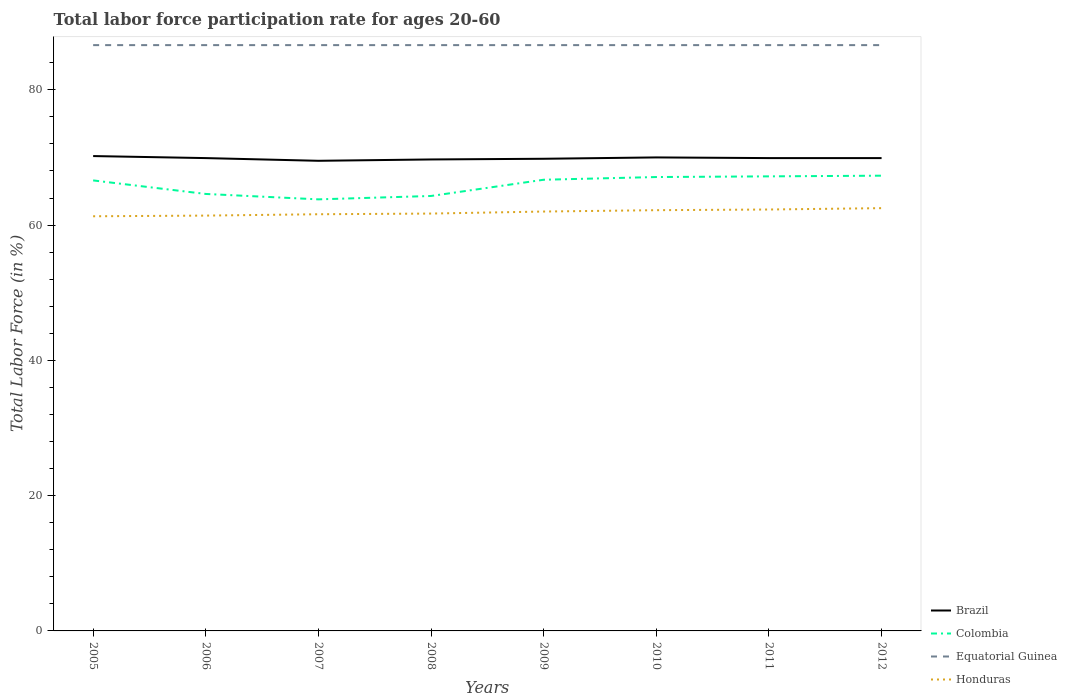Across all years, what is the maximum labor force participation rate in Brazil?
Offer a terse response. 69.5. In which year was the labor force participation rate in Honduras maximum?
Give a very brief answer. 2005. What is the total labor force participation rate in Brazil in the graph?
Provide a short and direct response. -0.4. What is the difference between the highest and the second highest labor force participation rate in Honduras?
Your answer should be compact. 1.2. Is the labor force participation rate in Brazil strictly greater than the labor force participation rate in Equatorial Guinea over the years?
Your response must be concise. Yes. How many years are there in the graph?
Make the answer very short. 8. What is the difference between two consecutive major ticks on the Y-axis?
Offer a very short reply. 20. Are the values on the major ticks of Y-axis written in scientific E-notation?
Your answer should be very brief. No. Does the graph contain any zero values?
Provide a short and direct response. No. Does the graph contain grids?
Offer a terse response. No. Where does the legend appear in the graph?
Offer a very short reply. Bottom right. What is the title of the graph?
Give a very brief answer. Total labor force participation rate for ages 20-60. Does "Palau" appear as one of the legend labels in the graph?
Keep it short and to the point. No. What is the Total Labor Force (in %) in Brazil in 2005?
Offer a terse response. 70.2. What is the Total Labor Force (in %) of Colombia in 2005?
Give a very brief answer. 66.6. What is the Total Labor Force (in %) in Equatorial Guinea in 2005?
Your answer should be very brief. 86.6. What is the Total Labor Force (in %) in Honduras in 2005?
Give a very brief answer. 61.3. What is the Total Labor Force (in %) of Brazil in 2006?
Make the answer very short. 69.9. What is the Total Labor Force (in %) of Colombia in 2006?
Offer a very short reply. 64.6. What is the Total Labor Force (in %) in Equatorial Guinea in 2006?
Your answer should be very brief. 86.6. What is the Total Labor Force (in %) of Honduras in 2006?
Your answer should be compact. 61.4. What is the Total Labor Force (in %) in Brazil in 2007?
Provide a short and direct response. 69.5. What is the Total Labor Force (in %) of Colombia in 2007?
Offer a terse response. 63.8. What is the Total Labor Force (in %) in Equatorial Guinea in 2007?
Provide a short and direct response. 86.6. What is the Total Labor Force (in %) in Honduras in 2007?
Your answer should be compact. 61.6. What is the Total Labor Force (in %) in Brazil in 2008?
Your answer should be compact. 69.7. What is the Total Labor Force (in %) of Colombia in 2008?
Your answer should be compact. 64.3. What is the Total Labor Force (in %) of Equatorial Guinea in 2008?
Your answer should be compact. 86.6. What is the Total Labor Force (in %) in Honduras in 2008?
Keep it short and to the point. 61.7. What is the Total Labor Force (in %) in Brazil in 2009?
Keep it short and to the point. 69.8. What is the Total Labor Force (in %) in Colombia in 2009?
Provide a succinct answer. 66.7. What is the Total Labor Force (in %) in Equatorial Guinea in 2009?
Provide a short and direct response. 86.6. What is the Total Labor Force (in %) of Colombia in 2010?
Offer a terse response. 67.1. What is the Total Labor Force (in %) of Equatorial Guinea in 2010?
Make the answer very short. 86.6. What is the Total Labor Force (in %) in Honduras in 2010?
Provide a succinct answer. 62.2. What is the Total Labor Force (in %) of Brazil in 2011?
Provide a succinct answer. 69.9. What is the Total Labor Force (in %) in Colombia in 2011?
Make the answer very short. 67.2. What is the Total Labor Force (in %) in Equatorial Guinea in 2011?
Your answer should be very brief. 86.6. What is the Total Labor Force (in %) of Honduras in 2011?
Keep it short and to the point. 62.3. What is the Total Labor Force (in %) in Brazil in 2012?
Your response must be concise. 69.9. What is the Total Labor Force (in %) of Colombia in 2012?
Ensure brevity in your answer.  67.3. What is the Total Labor Force (in %) in Equatorial Guinea in 2012?
Your answer should be compact. 86.6. What is the Total Labor Force (in %) of Honduras in 2012?
Keep it short and to the point. 62.5. Across all years, what is the maximum Total Labor Force (in %) in Brazil?
Your answer should be compact. 70.2. Across all years, what is the maximum Total Labor Force (in %) in Colombia?
Offer a very short reply. 67.3. Across all years, what is the maximum Total Labor Force (in %) of Equatorial Guinea?
Keep it short and to the point. 86.6. Across all years, what is the maximum Total Labor Force (in %) of Honduras?
Your response must be concise. 62.5. Across all years, what is the minimum Total Labor Force (in %) in Brazil?
Make the answer very short. 69.5. Across all years, what is the minimum Total Labor Force (in %) of Colombia?
Keep it short and to the point. 63.8. Across all years, what is the minimum Total Labor Force (in %) of Equatorial Guinea?
Your answer should be very brief. 86.6. Across all years, what is the minimum Total Labor Force (in %) of Honduras?
Ensure brevity in your answer.  61.3. What is the total Total Labor Force (in %) of Brazil in the graph?
Give a very brief answer. 558.9. What is the total Total Labor Force (in %) in Colombia in the graph?
Provide a short and direct response. 527.6. What is the total Total Labor Force (in %) of Equatorial Guinea in the graph?
Keep it short and to the point. 692.8. What is the total Total Labor Force (in %) in Honduras in the graph?
Your answer should be compact. 495. What is the difference between the Total Labor Force (in %) of Brazil in 2005 and that in 2006?
Make the answer very short. 0.3. What is the difference between the Total Labor Force (in %) in Colombia in 2005 and that in 2006?
Your response must be concise. 2. What is the difference between the Total Labor Force (in %) of Equatorial Guinea in 2005 and that in 2006?
Your answer should be compact. 0. What is the difference between the Total Labor Force (in %) of Honduras in 2005 and that in 2006?
Give a very brief answer. -0.1. What is the difference between the Total Labor Force (in %) of Colombia in 2005 and that in 2007?
Offer a very short reply. 2.8. What is the difference between the Total Labor Force (in %) in Equatorial Guinea in 2005 and that in 2007?
Make the answer very short. 0. What is the difference between the Total Labor Force (in %) in Brazil in 2005 and that in 2008?
Offer a terse response. 0.5. What is the difference between the Total Labor Force (in %) in Equatorial Guinea in 2005 and that in 2009?
Offer a very short reply. 0. What is the difference between the Total Labor Force (in %) in Brazil in 2005 and that in 2010?
Make the answer very short. 0.2. What is the difference between the Total Labor Force (in %) in Colombia in 2005 and that in 2010?
Give a very brief answer. -0.5. What is the difference between the Total Labor Force (in %) in Equatorial Guinea in 2005 and that in 2010?
Make the answer very short. 0. What is the difference between the Total Labor Force (in %) in Equatorial Guinea in 2005 and that in 2011?
Keep it short and to the point. 0. What is the difference between the Total Labor Force (in %) in Honduras in 2005 and that in 2011?
Offer a terse response. -1. What is the difference between the Total Labor Force (in %) of Colombia in 2005 and that in 2012?
Provide a short and direct response. -0.7. What is the difference between the Total Labor Force (in %) of Honduras in 2005 and that in 2012?
Keep it short and to the point. -1.2. What is the difference between the Total Labor Force (in %) of Brazil in 2006 and that in 2007?
Offer a terse response. 0.4. What is the difference between the Total Labor Force (in %) in Brazil in 2006 and that in 2008?
Your answer should be very brief. 0.2. What is the difference between the Total Labor Force (in %) of Colombia in 2006 and that in 2008?
Provide a succinct answer. 0.3. What is the difference between the Total Labor Force (in %) of Equatorial Guinea in 2006 and that in 2008?
Make the answer very short. 0. What is the difference between the Total Labor Force (in %) in Brazil in 2006 and that in 2009?
Offer a terse response. 0.1. What is the difference between the Total Labor Force (in %) in Equatorial Guinea in 2006 and that in 2009?
Provide a succinct answer. 0. What is the difference between the Total Labor Force (in %) in Brazil in 2006 and that in 2010?
Provide a succinct answer. -0.1. What is the difference between the Total Labor Force (in %) in Colombia in 2006 and that in 2010?
Offer a terse response. -2.5. What is the difference between the Total Labor Force (in %) of Honduras in 2006 and that in 2010?
Offer a very short reply. -0.8. What is the difference between the Total Labor Force (in %) in Brazil in 2006 and that in 2011?
Offer a very short reply. 0. What is the difference between the Total Labor Force (in %) of Colombia in 2006 and that in 2011?
Ensure brevity in your answer.  -2.6. What is the difference between the Total Labor Force (in %) of Honduras in 2006 and that in 2011?
Make the answer very short. -0.9. What is the difference between the Total Labor Force (in %) of Brazil in 2006 and that in 2012?
Provide a succinct answer. 0. What is the difference between the Total Labor Force (in %) of Colombia in 2006 and that in 2012?
Your answer should be very brief. -2.7. What is the difference between the Total Labor Force (in %) of Equatorial Guinea in 2007 and that in 2008?
Your response must be concise. 0. What is the difference between the Total Labor Force (in %) in Honduras in 2007 and that in 2008?
Give a very brief answer. -0.1. What is the difference between the Total Labor Force (in %) of Equatorial Guinea in 2007 and that in 2009?
Provide a succinct answer. 0. What is the difference between the Total Labor Force (in %) of Honduras in 2007 and that in 2009?
Provide a short and direct response. -0.4. What is the difference between the Total Labor Force (in %) of Colombia in 2007 and that in 2010?
Provide a short and direct response. -3.3. What is the difference between the Total Labor Force (in %) in Equatorial Guinea in 2007 and that in 2010?
Ensure brevity in your answer.  0. What is the difference between the Total Labor Force (in %) in Honduras in 2007 and that in 2010?
Ensure brevity in your answer.  -0.6. What is the difference between the Total Labor Force (in %) in Brazil in 2007 and that in 2011?
Provide a short and direct response. -0.4. What is the difference between the Total Labor Force (in %) of Equatorial Guinea in 2007 and that in 2011?
Give a very brief answer. 0. What is the difference between the Total Labor Force (in %) in Brazil in 2007 and that in 2012?
Offer a terse response. -0.4. What is the difference between the Total Labor Force (in %) in Colombia in 2007 and that in 2012?
Keep it short and to the point. -3.5. What is the difference between the Total Labor Force (in %) in Equatorial Guinea in 2007 and that in 2012?
Make the answer very short. 0. What is the difference between the Total Labor Force (in %) in Honduras in 2007 and that in 2012?
Your response must be concise. -0.9. What is the difference between the Total Labor Force (in %) in Brazil in 2008 and that in 2009?
Offer a terse response. -0.1. What is the difference between the Total Labor Force (in %) in Honduras in 2008 and that in 2009?
Keep it short and to the point. -0.3. What is the difference between the Total Labor Force (in %) in Brazil in 2008 and that in 2010?
Provide a short and direct response. -0.3. What is the difference between the Total Labor Force (in %) in Colombia in 2008 and that in 2010?
Your response must be concise. -2.8. What is the difference between the Total Labor Force (in %) in Honduras in 2008 and that in 2010?
Keep it short and to the point. -0.5. What is the difference between the Total Labor Force (in %) of Equatorial Guinea in 2008 and that in 2011?
Offer a very short reply. 0. What is the difference between the Total Labor Force (in %) in Colombia in 2008 and that in 2012?
Your answer should be very brief. -3. What is the difference between the Total Labor Force (in %) of Equatorial Guinea in 2008 and that in 2012?
Your response must be concise. 0. What is the difference between the Total Labor Force (in %) in Honduras in 2008 and that in 2012?
Your response must be concise. -0.8. What is the difference between the Total Labor Force (in %) of Equatorial Guinea in 2009 and that in 2010?
Ensure brevity in your answer.  0. What is the difference between the Total Labor Force (in %) in Honduras in 2009 and that in 2010?
Offer a very short reply. -0.2. What is the difference between the Total Labor Force (in %) in Brazil in 2009 and that in 2012?
Your answer should be very brief. -0.1. What is the difference between the Total Labor Force (in %) of Equatorial Guinea in 2009 and that in 2012?
Give a very brief answer. 0. What is the difference between the Total Labor Force (in %) of Honduras in 2009 and that in 2012?
Your response must be concise. -0.5. What is the difference between the Total Labor Force (in %) in Brazil in 2010 and that in 2011?
Give a very brief answer. 0.1. What is the difference between the Total Labor Force (in %) in Honduras in 2010 and that in 2011?
Give a very brief answer. -0.1. What is the difference between the Total Labor Force (in %) of Brazil in 2010 and that in 2012?
Your answer should be very brief. 0.1. What is the difference between the Total Labor Force (in %) in Colombia in 2010 and that in 2012?
Give a very brief answer. -0.2. What is the difference between the Total Labor Force (in %) in Brazil in 2005 and the Total Labor Force (in %) in Colombia in 2006?
Give a very brief answer. 5.6. What is the difference between the Total Labor Force (in %) of Brazil in 2005 and the Total Labor Force (in %) of Equatorial Guinea in 2006?
Provide a succinct answer. -16.4. What is the difference between the Total Labor Force (in %) in Colombia in 2005 and the Total Labor Force (in %) in Equatorial Guinea in 2006?
Make the answer very short. -20. What is the difference between the Total Labor Force (in %) of Equatorial Guinea in 2005 and the Total Labor Force (in %) of Honduras in 2006?
Ensure brevity in your answer.  25.2. What is the difference between the Total Labor Force (in %) in Brazil in 2005 and the Total Labor Force (in %) in Colombia in 2007?
Your answer should be compact. 6.4. What is the difference between the Total Labor Force (in %) in Brazil in 2005 and the Total Labor Force (in %) in Equatorial Guinea in 2007?
Offer a terse response. -16.4. What is the difference between the Total Labor Force (in %) of Brazil in 2005 and the Total Labor Force (in %) of Honduras in 2007?
Offer a terse response. 8.6. What is the difference between the Total Labor Force (in %) in Colombia in 2005 and the Total Labor Force (in %) in Equatorial Guinea in 2007?
Make the answer very short. -20. What is the difference between the Total Labor Force (in %) of Colombia in 2005 and the Total Labor Force (in %) of Honduras in 2007?
Keep it short and to the point. 5. What is the difference between the Total Labor Force (in %) of Equatorial Guinea in 2005 and the Total Labor Force (in %) of Honduras in 2007?
Your response must be concise. 25. What is the difference between the Total Labor Force (in %) in Brazil in 2005 and the Total Labor Force (in %) in Equatorial Guinea in 2008?
Make the answer very short. -16.4. What is the difference between the Total Labor Force (in %) of Equatorial Guinea in 2005 and the Total Labor Force (in %) of Honduras in 2008?
Make the answer very short. 24.9. What is the difference between the Total Labor Force (in %) of Brazil in 2005 and the Total Labor Force (in %) of Equatorial Guinea in 2009?
Your answer should be very brief. -16.4. What is the difference between the Total Labor Force (in %) in Brazil in 2005 and the Total Labor Force (in %) in Honduras in 2009?
Provide a succinct answer. 8.2. What is the difference between the Total Labor Force (in %) in Colombia in 2005 and the Total Labor Force (in %) in Honduras in 2009?
Provide a short and direct response. 4.6. What is the difference between the Total Labor Force (in %) of Equatorial Guinea in 2005 and the Total Labor Force (in %) of Honduras in 2009?
Keep it short and to the point. 24.6. What is the difference between the Total Labor Force (in %) of Brazil in 2005 and the Total Labor Force (in %) of Colombia in 2010?
Keep it short and to the point. 3.1. What is the difference between the Total Labor Force (in %) of Brazil in 2005 and the Total Labor Force (in %) of Equatorial Guinea in 2010?
Your answer should be very brief. -16.4. What is the difference between the Total Labor Force (in %) in Brazil in 2005 and the Total Labor Force (in %) in Honduras in 2010?
Provide a short and direct response. 8. What is the difference between the Total Labor Force (in %) of Colombia in 2005 and the Total Labor Force (in %) of Equatorial Guinea in 2010?
Provide a short and direct response. -20. What is the difference between the Total Labor Force (in %) of Equatorial Guinea in 2005 and the Total Labor Force (in %) of Honduras in 2010?
Provide a succinct answer. 24.4. What is the difference between the Total Labor Force (in %) in Brazil in 2005 and the Total Labor Force (in %) in Equatorial Guinea in 2011?
Provide a succinct answer. -16.4. What is the difference between the Total Labor Force (in %) in Brazil in 2005 and the Total Labor Force (in %) in Honduras in 2011?
Offer a terse response. 7.9. What is the difference between the Total Labor Force (in %) in Equatorial Guinea in 2005 and the Total Labor Force (in %) in Honduras in 2011?
Provide a short and direct response. 24.3. What is the difference between the Total Labor Force (in %) of Brazil in 2005 and the Total Labor Force (in %) of Colombia in 2012?
Offer a very short reply. 2.9. What is the difference between the Total Labor Force (in %) of Brazil in 2005 and the Total Labor Force (in %) of Equatorial Guinea in 2012?
Give a very brief answer. -16.4. What is the difference between the Total Labor Force (in %) in Colombia in 2005 and the Total Labor Force (in %) in Honduras in 2012?
Offer a terse response. 4.1. What is the difference between the Total Labor Force (in %) of Equatorial Guinea in 2005 and the Total Labor Force (in %) of Honduras in 2012?
Keep it short and to the point. 24.1. What is the difference between the Total Labor Force (in %) in Brazil in 2006 and the Total Labor Force (in %) in Colombia in 2007?
Offer a terse response. 6.1. What is the difference between the Total Labor Force (in %) in Brazil in 2006 and the Total Labor Force (in %) in Equatorial Guinea in 2007?
Ensure brevity in your answer.  -16.7. What is the difference between the Total Labor Force (in %) in Colombia in 2006 and the Total Labor Force (in %) in Equatorial Guinea in 2007?
Make the answer very short. -22. What is the difference between the Total Labor Force (in %) of Equatorial Guinea in 2006 and the Total Labor Force (in %) of Honduras in 2007?
Keep it short and to the point. 25. What is the difference between the Total Labor Force (in %) of Brazil in 2006 and the Total Labor Force (in %) of Colombia in 2008?
Offer a terse response. 5.6. What is the difference between the Total Labor Force (in %) in Brazil in 2006 and the Total Labor Force (in %) in Equatorial Guinea in 2008?
Offer a very short reply. -16.7. What is the difference between the Total Labor Force (in %) of Brazil in 2006 and the Total Labor Force (in %) of Honduras in 2008?
Keep it short and to the point. 8.2. What is the difference between the Total Labor Force (in %) of Colombia in 2006 and the Total Labor Force (in %) of Honduras in 2008?
Make the answer very short. 2.9. What is the difference between the Total Labor Force (in %) of Equatorial Guinea in 2006 and the Total Labor Force (in %) of Honduras in 2008?
Ensure brevity in your answer.  24.9. What is the difference between the Total Labor Force (in %) of Brazil in 2006 and the Total Labor Force (in %) of Equatorial Guinea in 2009?
Your answer should be compact. -16.7. What is the difference between the Total Labor Force (in %) in Brazil in 2006 and the Total Labor Force (in %) in Honduras in 2009?
Give a very brief answer. 7.9. What is the difference between the Total Labor Force (in %) in Colombia in 2006 and the Total Labor Force (in %) in Equatorial Guinea in 2009?
Offer a terse response. -22. What is the difference between the Total Labor Force (in %) of Colombia in 2006 and the Total Labor Force (in %) of Honduras in 2009?
Make the answer very short. 2.6. What is the difference between the Total Labor Force (in %) in Equatorial Guinea in 2006 and the Total Labor Force (in %) in Honduras in 2009?
Your response must be concise. 24.6. What is the difference between the Total Labor Force (in %) of Brazil in 2006 and the Total Labor Force (in %) of Equatorial Guinea in 2010?
Give a very brief answer. -16.7. What is the difference between the Total Labor Force (in %) in Brazil in 2006 and the Total Labor Force (in %) in Honduras in 2010?
Give a very brief answer. 7.7. What is the difference between the Total Labor Force (in %) in Colombia in 2006 and the Total Labor Force (in %) in Equatorial Guinea in 2010?
Offer a terse response. -22. What is the difference between the Total Labor Force (in %) of Equatorial Guinea in 2006 and the Total Labor Force (in %) of Honduras in 2010?
Keep it short and to the point. 24.4. What is the difference between the Total Labor Force (in %) in Brazil in 2006 and the Total Labor Force (in %) in Equatorial Guinea in 2011?
Your response must be concise. -16.7. What is the difference between the Total Labor Force (in %) of Colombia in 2006 and the Total Labor Force (in %) of Equatorial Guinea in 2011?
Offer a terse response. -22. What is the difference between the Total Labor Force (in %) of Equatorial Guinea in 2006 and the Total Labor Force (in %) of Honduras in 2011?
Make the answer very short. 24.3. What is the difference between the Total Labor Force (in %) in Brazil in 2006 and the Total Labor Force (in %) in Equatorial Guinea in 2012?
Give a very brief answer. -16.7. What is the difference between the Total Labor Force (in %) of Brazil in 2006 and the Total Labor Force (in %) of Honduras in 2012?
Your response must be concise. 7.4. What is the difference between the Total Labor Force (in %) of Equatorial Guinea in 2006 and the Total Labor Force (in %) of Honduras in 2012?
Your answer should be compact. 24.1. What is the difference between the Total Labor Force (in %) of Brazil in 2007 and the Total Labor Force (in %) of Equatorial Guinea in 2008?
Your answer should be compact. -17.1. What is the difference between the Total Labor Force (in %) of Brazil in 2007 and the Total Labor Force (in %) of Honduras in 2008?
Your answer should be compact. 7.8. What is the difference between the Total Labor Force (in %) in Colombia in 2007 and the Total Labor Force (in %) in Equatorial Guinea in 2008?
Provide a succinct answer. -22.8. What is the difference between the Total Labor Force (in %) in Equatorial Guinea in 2007 and the Total Labor Force (in %) in Honduras in 2008?
Your answer should be very brief. 24.9. What is the difference between the Total Labor Force (in %) in Brazil in 2007 and the Total Labor Force (in %) in Colombia in 2009?
Offer a very short reply. 2.8. What is the difference between the Total Labor Force (in %) of Brazil in 2007 and the Total Labor Force (in %) of Equatorial Guinea in 2009?
Make the answer very short. -17.1. What is the difference between the Total Labor Force (in %) in Brazil in 2007 and the Total Labor Force (in %) in Honduras in 2009?
Offer a very short reply. 7.5. What is the difference between the Total Labor Force (in %) of Colombia in 2007 and the Total Labor Force (in %) of Equatorial Guinea in 2009?
Keep it short and to the point. -22.8. What is the difference between the Total Labor Force (in %) of Colombia in 2007 and the Total Labor Force (in %) of Honduras in 2009?
Ensure brevity in your answer.  1.8. What is the difference between the Total Labor Force (in %) in Equatorial Guinea in 2007 and the Total Labor Force (in %) in Honduras in 2009?
Give a very brief answer. 24.6. What is the difference between the Total Labor Force (in %) in Brazil in 2007 and the Total Labor Force (in %) in Equatorial Guinea in 2010?
Make the answer very short. -17.1. What is the difference between the Total Labor Force (in %) in Colombia in 2007 and the Total Labor Force (in %) in Equatorial Guinea in 2010?
Give a very brief answer. -22.8. What is the difference between the Total Labor Force (in %) of Equatorial Guinea in 2007 and the Total Labor Force (in %) of Honduras in 2010?
Your answer should be very brief. 24.4. What is the difference between the Total Labor Force (in %) of Brazil in 2007 and the Total Labor Force (in %) of Colombia in 2011?
Your answer should be very brief. 2.3. What is the difference between the Total Labor Force (in %) in Brazil in 2007 and the Total Labor Force (in %) in Equatorial Guinea in 2011?
Keep it short and to the point. -17.1. What is the difference between the Total Labor Force (in %) in Brazil in 2007 and the Total Labor Force (in %) in Honduras in 2011?
Give a very brief answer. 7.2. What is the difference between the Total Labor Force (in %) of Colombia in 2007 and the Total Labor Force (in %) of Equatorial Guinea in 2011?
Provide a short and direct response. -22.8. What is the difference between the Total Labor Force (in %) in Colombia in 2007 and the Total Labor Force (in %) in Honduras in 2011?
Provide a short and direct response. 1.5. What is the difference between the Total Labor Force (in %) in Equatorial Guinea in 2007 and the Total Labor Force (in %) in Honduras in 2011?
Provide a succinct answer. 24.3. What is the difference between the Total Labor Force (in %) of Brazil in 2007 and the Total Labor Force (in %) of Equatorial Guinea in 2012?
Offer a very short reply. -17.1. What is the difference between the Total Labor Force (in %) of Colombia in 2007 and the Total Labor Force (in %) of Equatorial Guinea in 2012?
Provide a succinct answer. -22.8. What is the difference between the Total Labor Force (in %) of Equatorial Guinea in 2007 and the Total Labor Force (in %) of Honduras in 2012?
Offer a very short reply. 24.1. What is the difference between the Total Labor Force (in %) in Brazil in 2008 and the Total Labor Force (in %) in Equatorial Guinea in 2009?
Keep it short and to the point. -16.9. What is the difference between the Total Labor Force (in %) of Colombia in 2008 and the Total Labor Force (in %) of Equatorial Guinea in 2009?
Your answer should be very brief. -22.3. What is the difference between the Total Labor Force (in %) in Colombia in 2008 and the Total Labor Force (in %) in Honduras in 2009?
Keep it short and to the point. 2.3. What is the difference between the Total Labor Force (in %) of Equatorial Guinea in 2008 and the Total Labor Force (in %) of Honduras in 2009?
Ensure brevity in your answer.  24.6. What is the difference between the Total Labor Force (in %) of Brazil in 2008 and the Total Labor Force (in %) of Colombia in 2010?
Give a very brief answer. 2.6. What is the difference between the Total Labor Force (in %) in Brazil in 2008 and the Total Labor Force (in %) in Equatorial Guinea in 2010?
Provide a short and direct response. -16.9. What is the difference between the Total Labor Force (in %) of Brazil in 2008 and the Total Labor Force (in %) of Honduras in 2010?
Provide a short and direct response. 7.5. What is the difference between the Total Labor Force (in %) of Colombia in 2008 and the Total Labor Force (in %) of Equatorial Guinea in 2010?
Give a very brief answer. -22.3. What is the difference between the Total Labor Force (in %) in Equatorial Guinea in 2008 and the Total Labor Force (in %) in Honduras in 2010?
Ensure brevity in your answer.  24.4. What is the difference between the Total Labor Force (in %) of Brazil in 2008 and the Total Labor Force (in %) of Equatorial Guinea in 2011?
Your answer should be very brief. -16.9. What is the difference between the Total Labor Force (in %) in Colombia in 2008 and the Total Labor Force (in %) in Equatorial Guinea in 2011?
Give a very brief answer. -22.3. What is the difference between the Total Labor Force (in %) of Colombia in 2008 and the Total Labor Force (in %) of Honduras in 2011?
Offer a very short reply. 2. What is the difference between the Total Labor Force (in %) in Equatorial Guinea in 2008 and the Total Labor Force (in %) in Honduras in 2011?
Provide a short and direct response. 24.3. What is the difference between the Total Labor Force (in %) of Brazil in 2008 and the Total Labor Force (in %) of Colombia in 2012?
Provide a short and direct response. 2.4. What is the difference between the Total Labor Force (in %) in Brazil in 2008 and the Total Labor Force (in %) in Equatorial Guinea in 2012?
Keep it short and to the point. -16.9. What is the difference between the Total Labor Force (in %) of Brazil in 2008 and the Total Labor Force (in %) of Honduras in 2012?
Provide a short and direct response. 7.2. What is the difference between the Total Labor Force (in %) in Colombia in 2008 and the Total Labor Force (in %) in Equatorial Guinea in 2012?
Your response must be concise. -22.3. What is the difference between the Total Labor Force (in %) of Colombia in 2008 and the Total Labor Force (in %) of Honduras in 2012?
Offer a terse response. 1.8. What is the difference between the Total Labor Force (in %) in Equatorial Guinea in 2008 and the Total Labor Force (in %) in Honduras in 2012?
Your answer should be very brief. 24.1. What is the difference between the Total Labor Force (in %) in Brazil in 2009 and the Total Labor Force (in %) in Equatorial Guinea in 2010?
Offer a terse response. -16.8. What is the difference between the Total Labor Force (in %) in Brazil in 2009 and the Total Labor Force (in %) in Honduras in 2010?
Offer a very short reply. 7.6. What is the difference between the Total Labor Force (in %) in Colombia in 2009 and the Total Labor Force (in %) in Equatorial Guinea in 2010?
Make the answer very short. -19.9. What is the difference between the Total Labor Force (in %) in Colombia in 2009 and the Total Labor Force (in %) in Honduras in 2010?
Make the answer very short. 4.5. What is the difference between the Total Labor Force (in %) of Equatorial Guinea in 2009 and the Total Labor Force (in %) of Honduras in 2010?
Your answer should be very brief. 24.4. What is the difference between the Total Labor Force (in %) in Brazil in 2009 and the Total Labor Force (in %) in Colombia in 2011?
Offer a terse response. 2.6. What is the difference between the Total Labor Force (in %) of Brazil in 2009 and the Total Labor Force (in %) of Equatorial Guinea in 2011?
Provide a succinct answer. -16.8. What is the difference between the Total Labor Force (in %) of Colombia in 2009 and the Total Labor Force (in %) of Equatorial Guinea in 2011?
Ensure brevity in your answer.  -19.9. What is the difference between the Total Labor Force (in %) of Colombia in 2009 and the Total Labor Force (in %) of Honduras in 2011?
Ensure brevity in your answer.  4.4. What is the difference between the Total Labor Force (in %) in Equatorial Guinea in 2009 and the Total Labor Force (in %) in Honduras in 2011?
Your answer should be compact. 24.3. What is the difference between the Total Labor Force (in %) in Brazil in 2009 and the Total Labor Force (in %) in Colombia in 2012?
Provide a succinct answer. 2.5. What is the difference between the Total Labor Force (in %) in Brazil in 2009 and the Total Labor Force (in %) in Equatorial Guinea in 2012?
Your answer should be compact. -16.8. What is the difference between the Total Labor Force (in %) of Brazil in 2009 and the Total Labor Force (in %) of Honduras in 2012?
Keep it short and to the point. 7.3. What is the difference between the Total Labor Force (in %) of Colombia in 2009 and the Total Labor Force (in %) of Equatorial Guinea in 2012?
Provide a short and direct response. -19.9. What is the difference between the Total Labor Force (in %) of Equatorial Guinea in 2009 and the Total Labor Force (in %) of Honduras in 2012?
Keep it short and to the point. 24.1. What is the difference between the Total Labor Force (in %) in Brazil in 2010 and the Total Labor Force (in %) in Colombia in 2011?
Make the answer very short. 2.8. What is the difference between the Total Labor Force (in %) in Brazil in 2010 and the Total Labor Force (in %) in Equatorial Guinea in 2011?
Provide a short and direct response. -16.6. What is the difference between the Total Labor Force (in %) of Colombia in 2010 and the Total Labor Force (in %) of Equatorial Guinea in 2011?
Ensure brevity in your answer.  -19.5. What is the difference between the Total Labor Force (in %) in Equatorial Guinea in 2010 and the Total Labor Force (in %) in Honduras in 2011?
Make the answer very short. 24.3. What is the difference between the Total Labor Force (in %) in Brazil in 2010 and the Total Labor Force (in %) in Equatorial Guinea in 2012?
Provide a succinct answer. -16.6. What is the difference between the Total Labor Force (in %) of Colombia in 2010 and the Total Labor Force (in %) of Equatorial Guinea in 2012?
Keep it short and to the point. -19.5. What is the difference between the Total Labor Force (in %) in Equatorial Guinea in 2010 and the Total Labor Force (in %) in Honduras in 2012?
Your answer should be very brief. 24.1. What is the difference between the Total Labor Force (in %) in Brazil in 2011 and the Total Labor Force (in %) in Equatorial Guinea in 2012?
Your answer should be compact. -16.7. What is the difference between the Total Labor Force (in %) in Colombia in 2011 and the Total Labor Force (in %) in Equatorial Guinea in 2012?
Ensure brevity in your answer.  -19.4. What is the difference between the Total Labor Force (in %) of Equatorial Guinea in 2011 and the Total Labor Force (in %) of Honduras in 2012?
Your answer should be very brief. 24.1. What is the average Total Labor Force (in %) of Brazil per year?
Give a very brief answer. 69.86. What is the average Total Labor Force (in %) of Colombia per year?
Offer a terse response. 65.95. What is the average Total Labor Force (in %) in Equatorial Guinea per year?
Keep it short and to the point. 86.6. What is the average Total Labor Force (in %) in Honduras per year?
Ensure brevity in your answer.  61.88. In the year 2005, what is the difference between the Total Labor Force (in %) in Brazil and Total Labor Force (in %) in Colombia?
Your answer should be very brief. 3.6. In the year 2005, what is the difference between the Total Labor Force (in %) in Brazil and Total Labor Force (in %) in Equatorial Guinea?
Give a very brief answer. -16.4. In the year 2005, what is the difference between the Total Labor Force (in %) of Brazil and Total Labor Force (in %) of Honduras?
Keep it short and to the point. 8.9. In the year 2005, what is the difference between the Total Labor Force (in %) of Equatorial Guinea and Total Labor Force (in %) of Honduras?
Provide a short and direct response. 25.3. In the year 2006, what is the difference between the Total Labor Force (in %) in Brazil and Total Labor Force (in %) in Colombia?
Provide a succinct answer. 5.3. In the year 2006, what is the difference between the Total Labor Force (in %) in Brazil and Total Labor Force (in %) in Equatorial Guinea?
Ensure brevity in your answer.  -16.7. In the year 2006, what is the difference between the Total Labor Force (in %) of Brazil and Total Labor Force (in %) of Honduras?
Provide a succinct answer. 8.5. In the year 2006, what is the difference between the Total Labor Force (in %) in Colombia and Total Labor Force (in %) in Equatorial Guinea?
Provide a succinct answer. -22. In the year 2006, what is the difference between the Total Labor Force (in %) of Colombia and Total Labor Force (in %) of Honduras?
Make the answer very short. 3.2. In the year 2006, what is the difference between the Total Labor Force (in %) of Equatorial Guinea and Total Labor Force (in %) of Honduras?
Keep it short and to the point. 25.2. In the year 2007, what is the difference between the Total Labor Force (in %) in Brazil and Total Labor Force (in %) in Colombia?
Offer a terse response. 5.7. In the year 2007, what is the difference between the Total Labor Force (in %) of Brazil and Total Labor Force (in %) of Equatorial Guinea?
Your answer should be very brief. -17.1. In the year 2007, what is the difference between the Total Labor Force (in %) in Brazil and Total Labor Force (in %) in Honduras?
Offer a terse response. 7.9. In the year 2007, what is the difference between the Total Labor Force (in %) of Colombia and Total Labor Force (in %) of Equatorial Guinea?
Provide a succinct answer. -22.8. In the year 2008, what is the difference between the Total Labor Force (in %) of Brazil and Total Labor Force (in %) of Equatorial Guinea?
Your answer should be compact. -16.9. In the year 2008, what is the difference between the Total Labor Force (in %) of Colombia and Total Labor Force (in %) of Equatorial Guinea?
Provide a short and direct response. -22.3. In the year 2008, what is the difference between the Total Labor Force (in %) of Equatorial Guinea and Total Labor Force (in %) of Honduras?
Offer a terse response. 24.9. In the year 2009, what is the difference between the Total Labor Force (in %) of Brazil and Total Labor Force (in %) of Equatorial Guinea?
Your response must be concise. -16.8. In the year 2009, what is the difference between the Total Labor Force (in %) in Colombia and Total Labor Force (in %) in Equatorial Guinea?
Offer a very short reply. -19.9. In the year 2009, what is the difference between the Total Labor Force (in %) of Colombia and Total Labor Force (in %) of Honduras?
Provide a succinct answer. 4.7. In the year 2009, what is the difference between the Total Labor Force (in %) of Equatorial Guinea and Total Labor Force (in %) of Honduras?
Provide a short and direct response. 24.6. In the year 2010, what is the difference between the Total Labor Force (in %) in Brazil and Total Labor Force (in %) in Colombia?
Make the answer very short. 2.9. In the year 2010, what is the difference between the Total Labor Force (in %) in Brazil and Total Labor Force (in %) in Equatorial Guinea?
Offer a very short reply. -16.6. In the year 2010, what is the difference between the Total Labor Force (in %) in Brazil and Total Labor Force (in %) in Honduras?
Ensure brevity in your answer.  7.8. In the year 2010, what is the difference between the Total Labor Force (in %) in Colombia and Total Labor Force (in %) in Equatorial Guinea?
Offer a terse response. -19.5. In the year 2010, what is the difference between the Total Labor Force (in %) of Colombia and Total Labor Force (in %) of Honduras?
Provide a short and direct response. 4.9. In the year 2010, what is the difference between the Total Labor Force (in %) of Equatorial Guinea and Total Labor Force (in %) of Honduras?
Keep it short and to the point. 24.4. In the year 2011, what is the difference between the Total Labor Force (in %) of Brazil and Total Labor Force (in %) of Colombia?
Give a very brief answer. 2.7. In the year 2011, what is the difference between the Total Labor Force (in %) in Brazil and Total Labor Force (in %) in Equatorial Guinea?
Your response must be concise. -16.7. In the year 2011, what is the difference between the Total Labor Force (in %) of Colombia and Total Labor Force (in %) of Equatorial Guinea?
Your response must be concise. -19.4. In the year 2011, what is the difference between the Total Labor Force (in %) in Colombia and Total Labor Force (in %) in Honduras?
Your answer should be very brief. 4.9. In the year 2011, what is the difference between the Total Labor Force (in %) in Equatorial Guinea and Total Labor Force (in %) in Honduras?
Make the answer very short. 24.3. In the year 2012, what is the difference between the Total Labor Force (in %) in Brazil and Total Labor Force (in %) in Equatorial Guinea?
Offer a very short reply. -16.7. In the year 2012, what is the difference between the Total Labor Force (in %) of Colombia and Total Labor Force (in %) of Equatorial Guinea?
Offer a very short reply. -19.3. In the year 2012, what is the difference between the Total Labor Force (in %) of Equatorial Guinea and Total Labor Force (in %) of Honduras?
Give a very brief answer. 24.1. What is the ratio of the Total Labor Force (in %) of Brazil in 2005 to that in 2006?
Offer a very short reply. 1. What is the ratio of the Total Labor Force (in %) in Colombia in 2005 to that in 2006?
Ensure brevity in your answer.  1.03. What is the ratio of the Total Labor Force (in %) of Equatorial Guinea in 2005 to that in 2006?
Ensure brevity in your answer.  1. What is the ratio of the Total Labor Force (in %) of Colombia in 2005 to that in 2007?
Ensure brevity in your answer.  1.04. What is the ratio of the Total Labor Force (in %) of Equatorial Guinea in 2005 to that in 2007?
Provide a short and direct response. 1. What is the ratio of the Total Labor Force (in %) of Honduras in 2005 to that in 2007?
Provide a succinct answer. 1. What is the ratio of the Total Labor Force (in %) of Brazil in 2005 to that in 2008?
Offer a terse response. 1.01. What is the ratio of the Total Labor Force (in %) in Colombia in 2005 to that in 2008?
Offer a very short reply. 1.04. What is the ratio of the Total Labor Force (in %) of Colombia in 2005 to that in 2009?
Your response must be concise. 1. What is the ratio of the Total Labor Force (in %) in Equatorial Guinea in 2005 to that in 2009?
Give a very brief answer. 1. What is the ratio of the Total Labor Force (in %) in Honduras in 2005 to that in 2009?
Offer a very short reply. 0.99. What is the ratio of the Total Labor Force (in %) in Brazil in 2005 to that in 2010?
Ensure brevity in your answer.  1. What is the ratio of the Total Labor Force (in %) of Colombia in 2005 to that in 2010?
Give a very brief answer. 0.99. What is the ratio of the Total Labor Force (in %) of Equatorial Guinea in 2005 to that in 2010?
Offer a terse response. 1. What is the ratio of the Total Labor Force (in %) in Honduras in 2005 to that in 2010?
Keep it short and to the point. 0.99. What is the ratio of the Total Labor Force (in %) of Colombia in 2005 to that in 2011?
Make the answer very short. 0.99. What is the ratio of the Total Labor Force (in %) in Honduras in 2005 to that in 2011?
Your answer should be compact. 0.98. What is the ratio of the Total Labor Force (in %) in Colombia in 2005 to that in 2012?
Provide a short and direct response. 0.99. What is the ratio of the Total Labor Force (in %) of Equatorial Guinea in 2005 to that in 2012?
Ensure brevity in your answer.  1. What is the ratio of the Total Labor Force (in %) of Honduras in 2005 to that in 2012?
Your answer should be very brief. 0.98. What is the ratio of the Total Labor Force (in %) of Brazil in 2006 to that in 2007?
Provide a short and direct response. 1.01. What is the ratio of the Total Labor Force (in %) in Colombia in 2006 to that in 2007?
Ensure brevity in your answer.  1.01. What is the ratio of the Total Labor Force (in %) of Honduras in 2006 to that in 2007?
Your answer should be very brief. 1. What is the ratio of the Total Labor Force (in %) in Brazil in 2006 to that in 2008?
Provide a succinct answer. 1. What is the ratio of the Total Labor Force (in %) of Colombia in 2006 to that in 2008?
Ensure brevity in your answer.  1. What is the ratio of the Total Labor Force (in %) in Equatorial Guinea in 2006 to that in 2008?
Your answer should be compact. 1. What is the ratio of the Total Labor Force (in %) of Honduras in 2006 to that in 2008?
Give a very brief answer. 1. What is the ratio of the Total Labor Force (in %) in Colombia in 2006 to that in 2009?
Ensure brevity in your answer.  0.97. What is the ratio of the Total Labor Force (in %) of Honduras in 2006 to that in 2009?
Make the answer very short. 0.99. What is the ratio of the Total Labor Force (in %) of Brazil in 2006 to that in 2010?
Your response must be concise. 1. What is the ratio of the Total Labor Force (in %) of Colombia in 2006 to that in 2010?
Ensure brevity in your answer.  0.96. What is the ratio of the Total Labor Force (in %) in Honduras in 2006 to that in 2010?
Make the answer very short. 0.99. What is the ratio of the Total Labor Force (in %) of Brazil in 2006 to that in 2011?
Offer a very short reply. 1. What is the ratio of the Total Labor Force (in %) in Colombia in 2006 to that in 2011?
Offer a terse response. 0.96. What is the ratio of the Total Labor Force (in %) in Honduras in 2006 to that in 2011?
Provide a succinct answer. 0.99. What is the ratio of the Total Labor Force (in %) in Brazil in 2006 to that in 2012?
Your response must be concise. 1. What is the ratio of the Total Labor Force (in %) in Colombia in 2006 to that in 2012?
Your answer should be compact. 0.96. What is the ratio of the Total Labor Force (in %) in Equatorial Guinea in 2006 to that in 2012?
Your answer should be compact. 1. What is the ratio of the Total Labor Force (in %) in Honduras in 2006 to that in 2012?
Provide a short and direct response. 0.98. What is the ratio of the Total Labor Force (in %) in Brazil in 2007 to that in 2009?
Your response must be concise. 1. What is the ratio of the Total Labor Force (in %) in Colombia in 2007 to that in 2009?
Your answer should be very brief. 0.96. What is the ratio of the Total Labor Force (in %) of Honduras in 2007 to that in 2009?
Provide a short and direct response. 0.99. What is the ratio of the Total Labor Force (in %) in Brazil in 2007 to that in 2010?
Your answer should be compact. 0.99. What is the ratio of the Total Labor Force (in %) of Colombia in 2007 to that in 2010?
Provide a succinct answer. 0.95. What is the ratio of the Total Labor Force (in %) of Equatorial Guinea in 2007 to that in 2010?
Make the answer very short. 1. What is the ratio of the Total Labor Force (in %) in Colombia in 2007 to that in 2011?
Provide a short and direct response. 0.95. What is the ratio of the Total Labor Force (in %) in Equatorial Guinea in 2007 to that in 2011?
Provide a succinct answer. 1. What is the ratio of the Total Labor Force (in %) of Honduras in 2007 to that in 2011?
Make the answer very short. 0.99. What is the ratio of the Total Labor Force (in %) of Colombia in 2007 to that in 2012?
Your answer should be compact. 0.95. What is the ratio of the Total Labor Force (in %) of Equatorial Guinea in 2007 to that in 2012?
Give a very brief answer. 1. What is the ratio of the Total Labor Force (in %) of Honduras in 2007 to that in 2012?
Offer a terse response. 0.99. What is the ratio of the Total Labor Force (in %) in Brazil in 2008 to that in 2010?
Provide a short and direct response. 1. What is the ratio of the Total Labor Force (in %) in Honduras in 2008 to that in 2010?
Your answer should be very brief. 0.99. What is the ratio of the Total Labor Force (in %) in Brazil in 2008 to that in 2011?
Provide a succinct answer. 1. What is the ratio of the Total Labor Force (in %) in Colombia in 2008 to that in 2011?
Your answer should be compact. 0.96. What is the ratio of the Total Labor Force (in %) in Honduras in 2008 to that in 2011?
Your answer should be compact. 0.99. What is the ratio of the Total Labor Force (in %) of Brazil in 2008 to that in 2012?
Provide a succinct answer. 1. What is the ratio of the Total Labor Force (in %) in Colombia in 2008 to that in 2012?
Your answer should be very brief. 0.96. What is the ratio of the Total Labor Force (in %) in Honduras in 2008 to that in 2012?
Offer a very short reply. 0.99. What is the ratio of the Total Labor Force (in %) of Equatorial Guinea in 2009 to that in 2010?
Offer a very short reply. 1. What is the ratio of the Total Labor Force (in %) in Honduras in 2009 to that in 2010?
Your response must be concise. 1. What is the ratio of the Total Labor Force (in %) in Equatorial Guinea in 2009 to that in 2012?
Give a very brief answer. 1. What is the ratio of the Total Labor Force (in %) in Colombia in 2010 to that in 2011?
Your answer should be compact. 1. What is the ratio of the Total Labor Force (in %) in Equatorial Guinea in 2010 to that in 2011?
Give a very brief answer. 1. What is the ratio of the Total Labor Force (in %) of Honduras in 2010 to that in 2011?
Make the answer very short. 1. What is the ratio of the Total Labor Force (in %) in Honduras in 2010 to that in 2012?
Provide a succinct answer. 1. What is the ratio of the Total Labor Force (in %) of Colombia in 2011 to that in 2012?
Your answer should be compact. 1. What is the ratio of the Total Labor Force (in %) of Honduras in 2011 to that in 2012?
Make the answer very short. 1. What is the difference between the highest and the second highest Total Labor Force (in %) of Brazil?
Your response must be concise. 0.2. What is the difference between the highest and the second highest Total Labor Force (in %) of Equatorial Guinea?
Make the answer very short. 0. What is the difference between the highest and the lowest Total Labor Force (in %) in Honduras?
Offer a terse response. 1.2. 